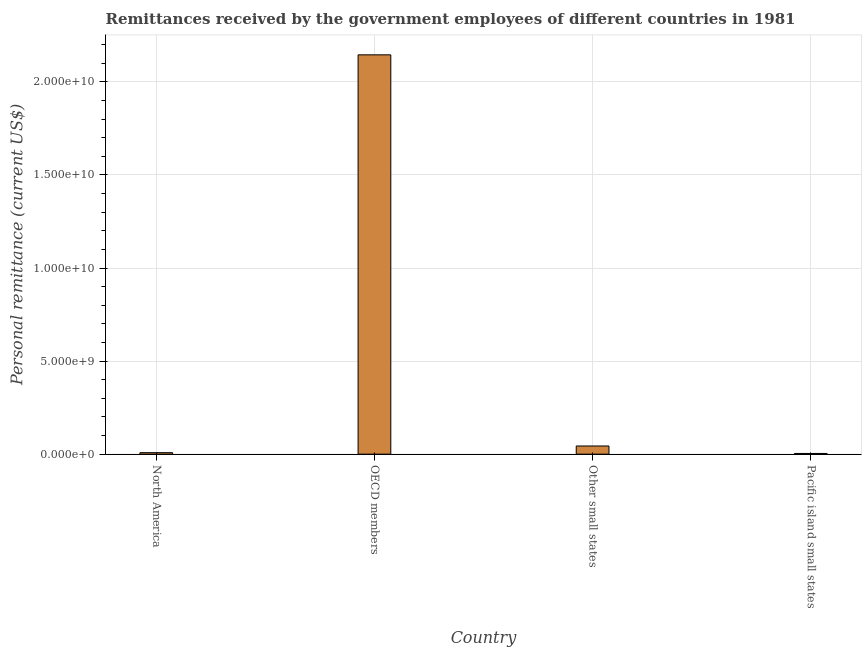What is the title of the graph?
Provide a succinct answer. Remittances received by the government employees of different countries in 1981. What is the label or title of the X-axis?
Keep it short and to the point. Country. What is the label or title of the Y-axis?
Offer a very short reply. Personal remittance (current US$). What is the personal remittances in OECD members?
Give a very brief answer. 2.15e+1. Across all countries, what is the maximum personal remittances?
Make the answer very short. 2.15e+1. Across all countries, what is the minimum personal remittances?
Your response must be concise. 3.79e+07. In which country was the personal remittances minimum?
Your answer should be very brief. Pacific island small states. What is the sum of the personal remittances?
Provide a succinct answer. 2.20e+1. What is the difference between the personal remittances in North America and Other small states?
Your answer should be very brief. -3.59e+08. What is the average personal remittances per country?
Provide a short and direct response. 5.50e+09. What is the median personal remittances?
Give a very brief answer. 2.60e+08. In how many countries, is the personal remittances greater than 6000000000 US$?
Provide a succinct answer. 1. What is the ratio of the personal remittances in North America to that in Other small states?
Make the answer very short. 0.18. Is the personal remittances in OECD members less than that in Pacific island small states?
Provide a succinct answer. No. What is the difference between the highest and the second highest personal remittances?
Your answer should be very brief. 2.10e+1. Is the sum of the personal remittances in OECD members and Other small states greater than the maximum personal remittances across all countries?
Provide a succinct answer. Yes. What is the difference between the highest and the lowest personal remittances?
Keep it short and to the point. 2.14e+1. How many bars are there?
Ensure brevity in your answer.  4. How many countries are there in the graph?
Provide a succinct answer. 4. What is the Personal remittance (current US$) of North America?
Provide a succinct answer. 8.00e+07. What is the Personal remittance (current US$) of OECD members?
Make the answer very short. 2.15e+1. What is the Personal remittance (current US$) of Other small states?
Offer a very short reply. 4.39e+08. What is the Personal remittance (current US$) in Pacific island small states?
Keep it short and to the point. 3.79e+07. What is the difference between the Personal remittance (current US$) in North America and OECD members?
Provide a short and direct response. -2.14e+1. What is the difference between the Personal remittance (current US$) in North America and Other small states?
Make the answer very short. -3.59e+08. What is the difference between the Personal remittance (current US$) in North America and Pacific island small states?
Ensure brevity in your answer.  4.21e+07. What is the difference between the Personal remittance (current US$) in OECD members and Other small states?
Make the answer very short. 2.10e+1. What is the difference between the Personal remittance (current US$) in OECD members and Pacific island small states?
Provide a succinct answer. 2.14e+1. What is the difference between the Personal remittance (current US$) in Other small states and Pacific island small states?
Provide a succinct answer. 4.01e+08. What is the ratio of the Personal remittance (current US$) in North America to that in OECD members?
Ensure brevity in your answer.  0. What is the ratio of the Personal remittance (current US$) in North America to that in Other small states?
Make the answer very short. 0.18. What is the ratio of the Personal remittance (current US$) in North America to that in Pacific island small states?
Keep it short and to the point. 2.11. What is the ratio of the Personal remittance (current US$) in OECD members to that in Other small states?
Ensure brevity in your answer.  48.84. What is the ratio of the Personal remittance (current US$) in OECD members to that in Pacific island small states?
Your answer should be very brief. 566.71. What is the ratio of the Personal remittance (current US$) in Other small states to that in Pacific island small states?
Your answer should be compact. 11.61. 